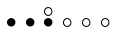<formula> <loc_0><loc_0><loc_500><loc_500>\begin{smallmatrix} & & \circ \\ \bullet & \bullet & \bullet & \circ & \circ & \circ & \\ \end{smallmatrix}</formula> 